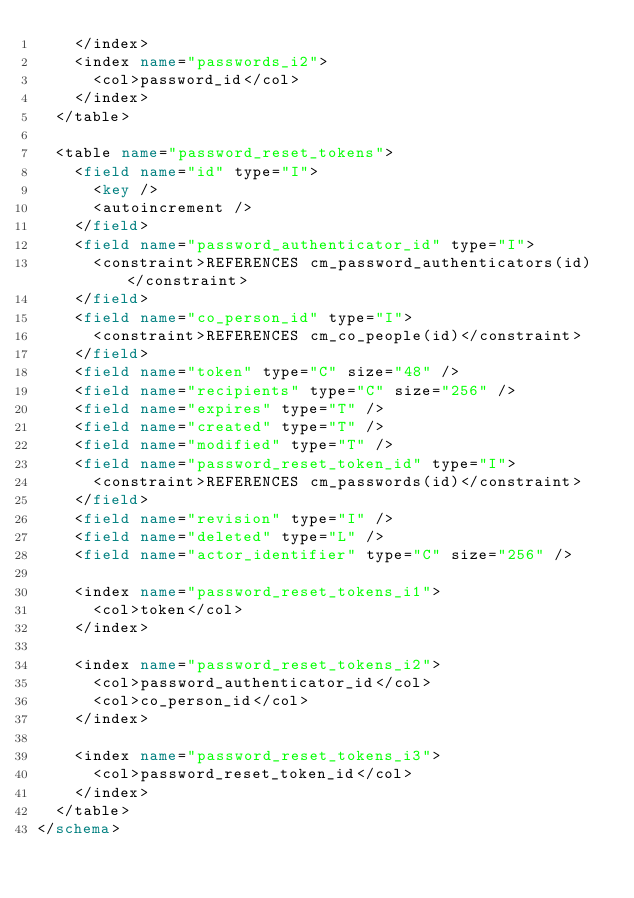Convert code to text. <code><loc_0><loc_0><loc_500><loc_500><_XML_>    </index>
    <index name="passwords_i2">
      <col>password_id</col>
    </index>
  </table>
  
  <table name="password_reset_tokens">
    <field name="id" type="I">
      <key />
      <autoincrement />
    </field>
    <field name="password_authenticator_id" type="I">
      <constraint>REFERENCES cm_password_authenticators(id)</constraint>
    </field>
    <field name="co_person_id" type="I">
      <constraint>REFERENCES cm_co_people(id)</constraint>
    </field>
    <field name="token" type="C" size="48" />
    <field name="recipients" type="C" size="256" />
    <field name="expires" type="T" />
    <field name="created" type="T" />
    <field name="modified" type="T" />
    <field name="password_reset_token_id" type="I">
      <constraint>REFERENCES cm_passwords(id)</constraint>
    </field>
    <field name="revision" type="I" />
    <field name="deleted" type="L" />
    <field name="actor_identifier" type="C" size="256" />
    
    <index name="password_reset_tokens_i1">
      <col>token</col>
    </index>
    
    <index name="password_reset_tokens_i2">
      <col>password_authenticator_id</col>
      <col>co_person_id</col>
    </index>
    
    <index name="password_reset_tokens_i3">
      <col>password_reset_token_id</col>
    </index>
  </table>
</schema></code> 